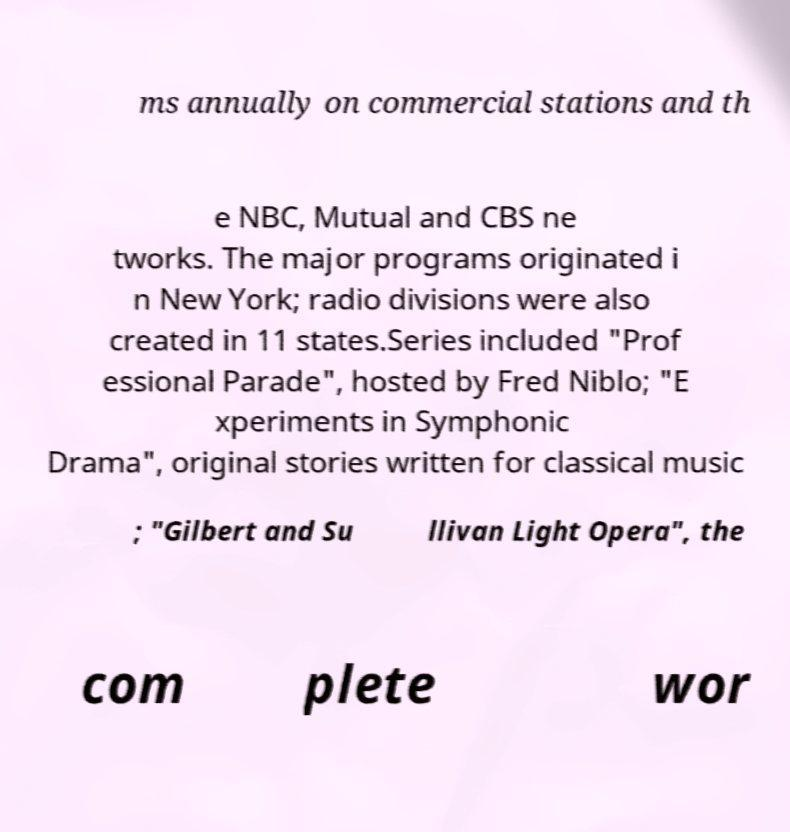Can you read and provide the text displayed in the image?This photo seems to have some interesting text. Can you extract and type it out for me? ms annually on commercial stations and th e NBC, Mutual and CBS ne tworks. The major programs originated i n New York; radio divisions were also created in 11 states.Series included "Prof essional Parade", hosted by Fred Niblo; "E xperiments in Symphonic Drama", original stories written for classical music ; "Gilbert and Su llivan Light Opera", the com plete wor 